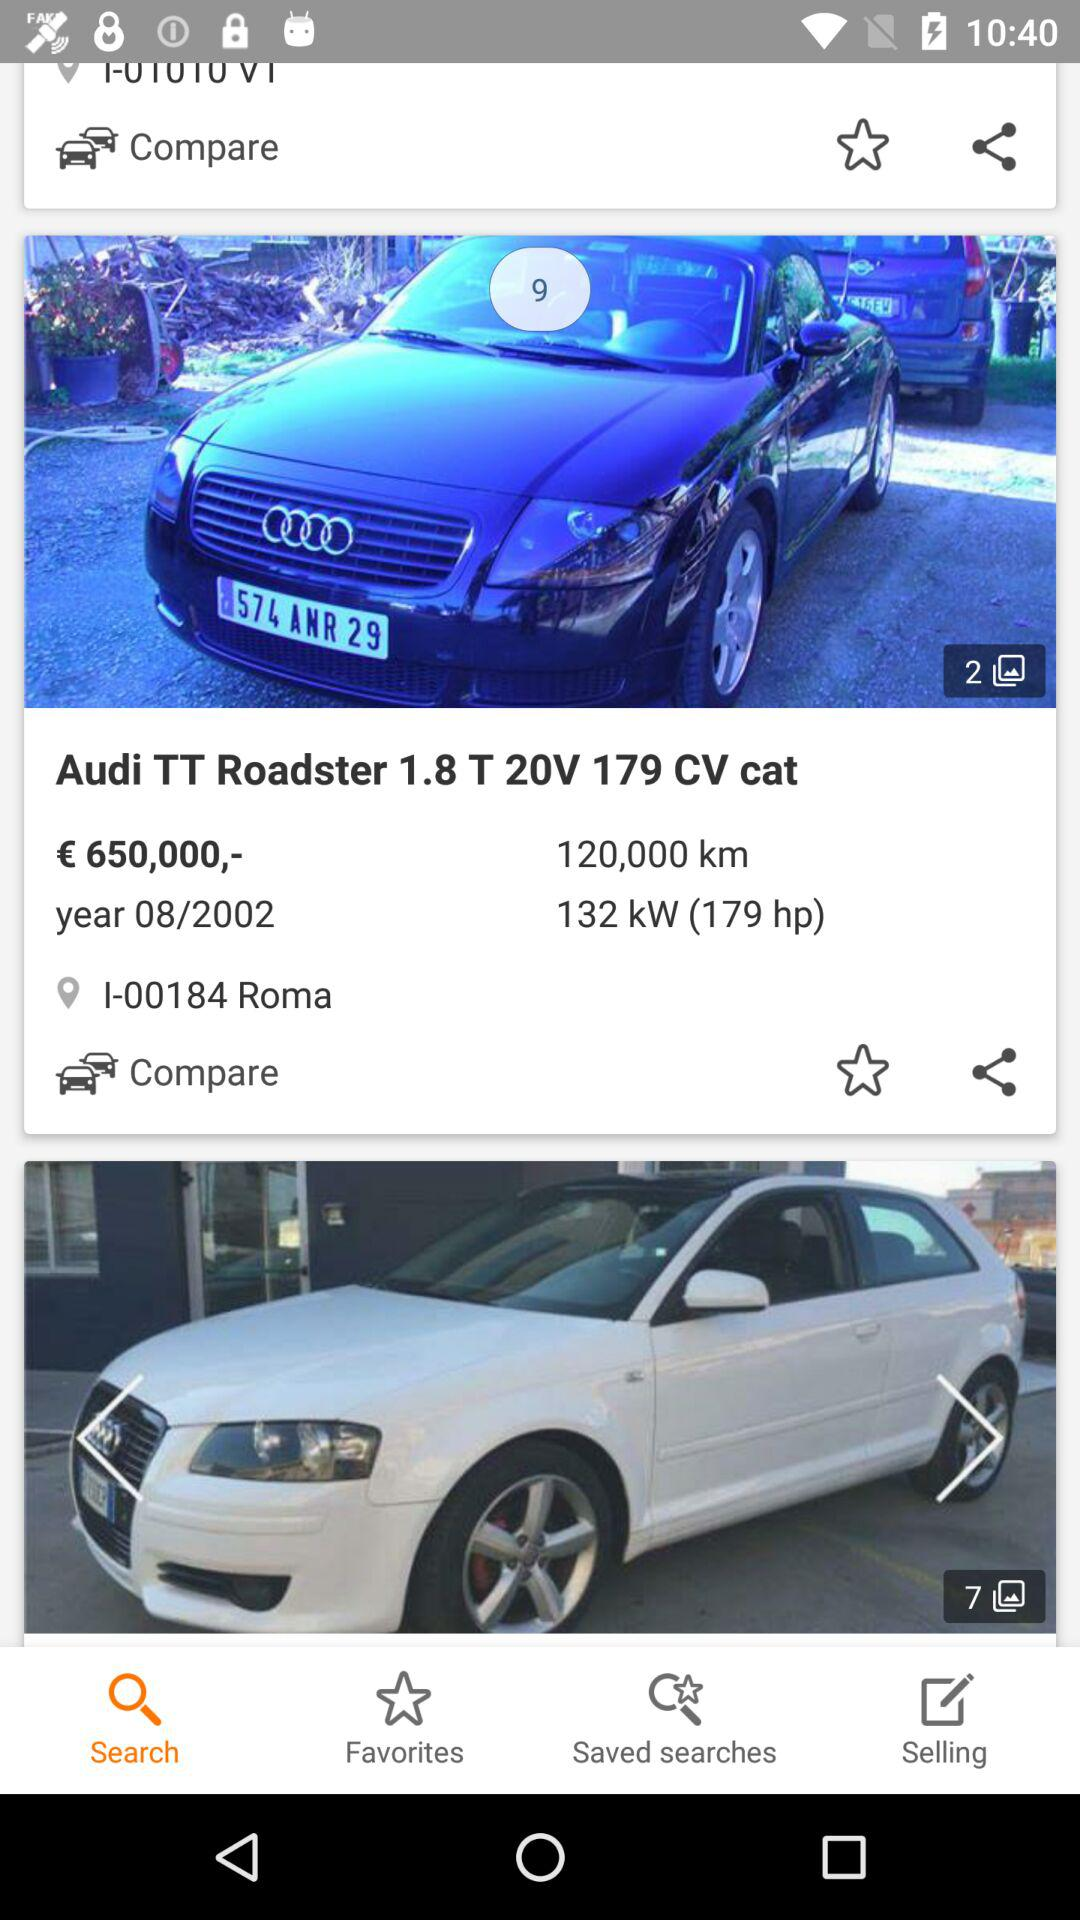Which tab is selected? The selected tab is "Search". 